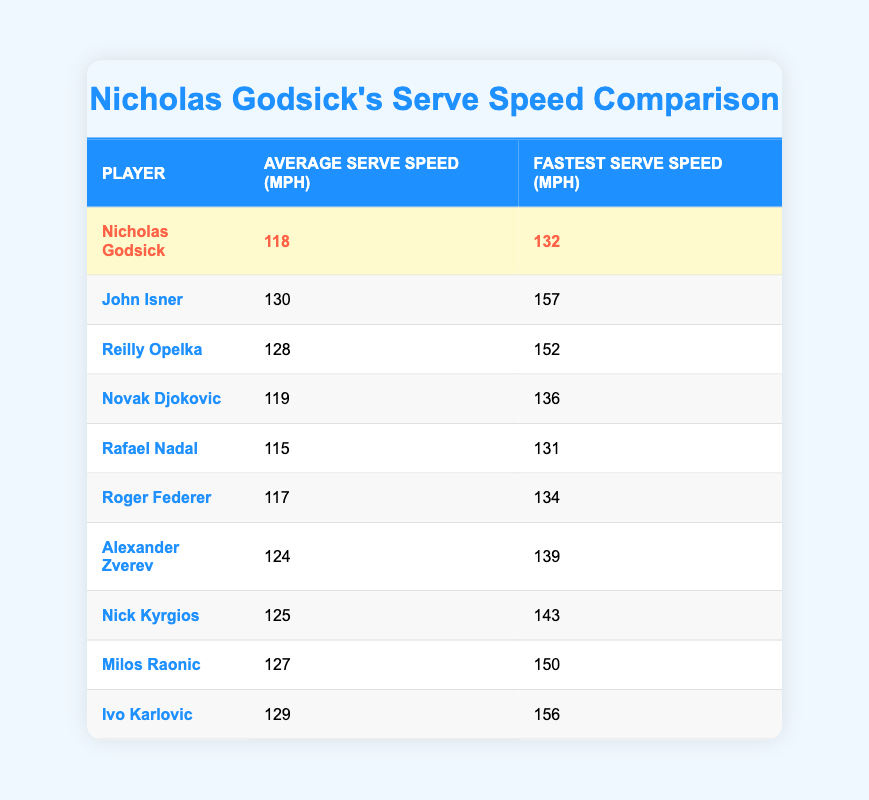What is Nicholas Godsick's average serve speed? Referring to the table, the average serve speed for Nicholas Godsick is given in the second column next to his name. It shows 118 mph.
Answer: 118 mph Who has the fastest serve recorded in the table? To find the fastest serve, look at the third column for each player. The highest value is 157 mph, attributed to John Isner.
Answer: John Isner What is the average of Nicholas Godsick's fastest serve speed compared to Rafael Nadal's fastest serve speed? Nicholas Godsick's fastest serve is 132 mph and Rafael Nadal's is 131 mph. The average of both is (132 + 131) / 2 = 131.5 mph.
Answer: 131.5 mph Is it true that Alexander Zverev has a higher average serve speed than Roger Federer? Checking the average serve speeds in the table, Alexander Zverev's is 124 mph, while Roger Federer's is 117 mph. Since 124 is greater than 117, the statement is true.
Answer: Yes What is the difference between the fastest serves of Ivo Karlovic and John Isner? The fastest serve for John Isner is 157 mph and for Ivo Karlovic is 156 mph. The difference is calculated as 157 - 156 = 1 mph.
Answer: 1 mph Which player has an average serve speed closest to Nicholas Godsick's? Nicholas Godsick has an average serve speed of 118 mph. The closest values in the table are Novak Djokovic with 119 mph and Roger Federer with 117 mph. Both values are only 1 mph away.
Answer: Novak Djokovic and Roger Federer How many players have an average serve speed above 125 mph? Looking through the average serve speeds in the table, those above 125 mph are John Isner (130), Reilly Opelka (128), Alexander Zverev (124), Nick Kyrgios (125), Milos Raonic (127), and Ivo Karlovic (129). Counting these players gives a total of 5.
Answer: 5 players What is the difference in average serve speed between the fastest and slowest players in the list? To find this, identify the highest average serve speed (John Isner at 130 mph) and the lowest (Rafael Nadal at 115 mph). The difference is 130 - 115 = 15 mph.
Answer: 15 mph What is the fastest serve speed recorded by Nick Kyrgios? The table indicates that Nick Kyrgios has a fastest serve speed listed in the third column. It shows 143 mph next to his name.
Answer: 143 mph 